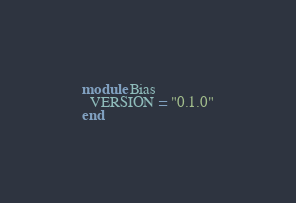Convert code to text. <code><loc_0><loc_0><loc_500><loc_500><_Ruby_>module Bias
  VERSION = "0.1.0"
end
</code> 